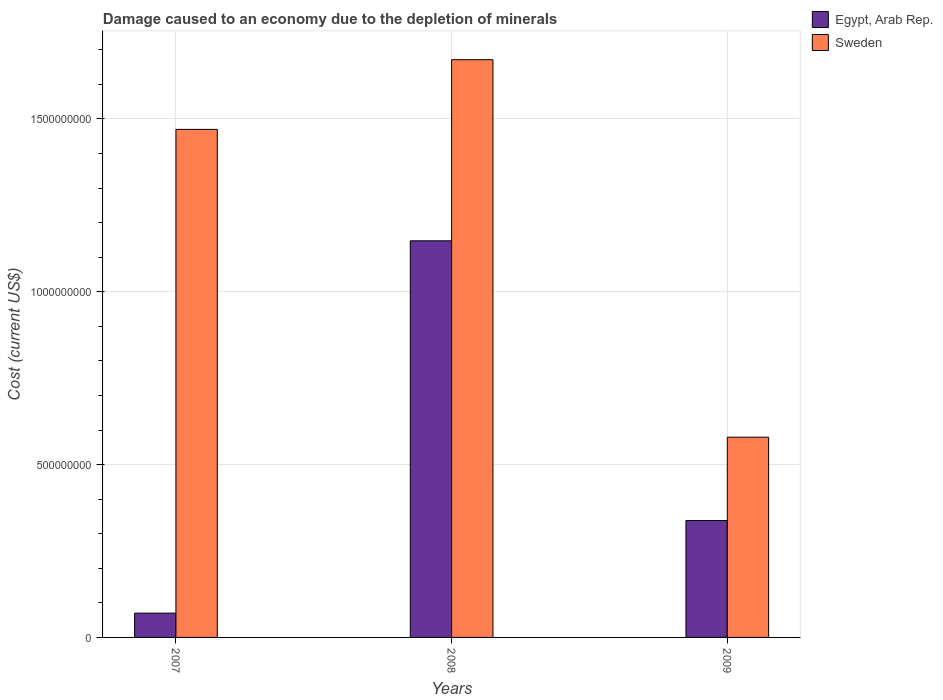How many different coloured bars are there?
Your answer should be very brief. 2. How many groups of bars are there?
Your answer should be compact. 3. Are the number of bars per tick equal to the number of legend labels?
Offer a terse response. Yes. How many bars are there on the 2nd tick from the left?
Offer a very short reply. 2. What is the label of the 2nd group of bars from the left?
Ensure brevity in your answer.  2008. What is the cost of damage caused due to the depletion of minerals in Sweden in 2008?
Provide a short and direct response. 1.67e+09. Across all years, what is the maximum cost of damage caused due to the depletion of minerals in Egypt, Arab Rep.?
Ensure brevity in your answer.  1.15e+09. Across all years, what is the minimum cost of damage caused due to the depletion of minerals in Sweden?
Keep it short and to the point. 5.79e+08. In which year was the cost of damage caused due to the depletion of minerals in Sweden minimum?
Give a very brief answer. 2009. What is the total cost of damage caused due to the depletion of minerals in Sweden in the graph?
Offer a terse response. 3.72e+09. What is the difference between the cost of damage caused due to the depletion of minerals in Egypt, Arab Rep. in 2007 and that in 2009?
Offer a terse response. -2.68e+08. What is the difference between the cost of damage caused due to the depletion of minerals in Sweden in 2007 and the cost of damage caused due to the depletion of minerals in Egypt, Arab Rep. in 2008?
Give a very brief answer. 3.22e+08. What is the average cost of damage caused due to the depletion of minerals in Egypt, Arab Rep. per year?
Ensure brevity in your answer.  5.19e+08. In the year 2007, what is the difference between the cost of damage caused due to the depletion of minerals in Sweden and cost of damage caused due to the depletion of minerals in Egypt, Arab Rep.?
Your response must be concise. 1.40e+09. What is the ratio of the cost of damage caused due to the depletion of minerals in Sweden in 2007 to that in 2008?
Ensure brevity in your answer.  0.88. What is the difference between the highest and the second highest cost of damage caused due to the depletion of minerals in Egypt, Arab Rep.?
Offer a very short reply. 8.09e+08. What is the difference between the highest and the lowest cost of damage caused due to the depletion of minerals in Egypt, Arab Rep.?
Provide a short and direct response. 1.08e+09. What does the 2nd bar from the left in 2009 represents?
Keep it short and to the point. Sweden. What does the 1st bar from the right in 2008 represents?
Give a very brief answer. Sweden. How many bars are there?
Offer a very short reply. 6. Does the graph contain any zero values?
Keep it short and to the point. No. Does the graph contain grids?
Offer a very short reply. Yes. How are the legend labels stacked?
Keep it short and to the point. Vertical. What is the title of the graph?
Offer a very short reply. Damage caused to an economy due to the depletion of minerals. Does "Pakistan" appear as one of the legend labels in the graph?
Ensure brevity in your answer.  No. What is the label or title of the X-axis?
Give a very brief answer. Years. What is the label or title of the Y-axis?
Make the answer very short. Cost (current US$). What is the Cost (current US$) of Egypt, Arab Rep. in 2007?
Your response must be concise. 7.03e+07. What is the Cost (current US$) in Sweden in 2007?
Give a very brief answer. 1.47e+09. What is the Cost (current US$) in Egypt, Arab Rep. in 2008?
Your answer should be compact. 1.15e+09. What is the Cost (current US$) of Sweden in 2008?
Provide a succinct answer. 1.67e+09. What is the Cost (current US$) of Egypt, Arab Rep. in 2009?
Offer a very short reply. 3.38e+08. What is the Cost (current US$) of Sweden in 2009?
Give a very brief answer. 5.79e+08. Across all years, what is the maximum Cost (current US$) of Egypt, Arab Rep.?
Make the answer very short. 1.15e+09. Across all years, what is the maximum Cost (current US$) of Sweden?
Offer a very short reply. 1.67e+09. Across all years, what is the minimum Cost (current US$) of Egypt, Arab Rep.?
Keep it short and to the point. 7.03e+07. Across all years, what is the minimum Cost (current US$) of Sweden?
Keep it short and to the point. 5.79e+08. What is the total Cost (current US$) in Egypt, Arab Rep. in the graph?
Make the answer very short. 1.56e+09. What is the total Cost (current US$) of Sweden in the graph?
Keep it short and to the point. 3.72e+09. What is the difference between the Cost (current US$) in Egypt, Arab Rep. in 2007 and that in 2008?
Make the answer very short. -1.08e+09. What is the difference between the Cost (current US$) of Sweden in 2007 and that in 2008?
Keep it short and to the point. -2.02e+08. What is the difference between the Cost (current US$) in Egypt, Arab Rep. in 2007 and that in 2009?
Make the answer very short. -2.68e+08. What is the difference between the Cost (current US$) of Sweden in 2007 and that in 2009?
Make the answer very short. 8.91e+08. What is the difference between the Cost (current US$) in Egypt, Arab Rep. in 2008 and that in 2009?
Provide a succinct answer. 8.09e+08. What is the difference between the Cost (current US$) in Sweden in 2008 and that in 2009?
Offer a terse response. 1.09e+09. What is the difference between the Cost (current US$) in Egypt, Arab Rep. in 2007 and the Cost (current US$) in Sweden in 2008?
Give a very brief answer. -1.60e+09. What is the difference between the Cost (current US$) in Egypt, Arab Rep. in 2007 and the Cost (current US$) in Sweden in 2009?
Offer a terse response. -5.09e+08. What is the difference between the Cost (current US$) of Egypt, Arab Rep. in 2008 and the Cost (current US$) of Sweden in 2009?
Your answer should be compact. 5.68e+08. What is the average Cost (current US$) in Egypt, Arab Rep. per year?
Offer a very short reply. 5.19e+08. What is the average Cost (current US$) in Sweden per year?
Your answer should be compact. 1.24e+09. In the year 2007, what is the difference between the Cost (current US$) in Egypt, Arab Rep. and Cost (current US$) in Sweden?
Ensure brevity in your answer.  -1.40e+09. In the year 2008, what is the difference between the Cost (current US$) in Egypt, Arab Rep. and Cost (current US$) in Sweden?
Offer a terse response. -5.24e+08. In the year 2009, what is the difference between the Cost (current US$) in Egypt, Arab Rep. and Cost (current US$) in Sweden?
Offer a terse response. -2.41e+08. What is the ratio of the Cost (current US$) in Egypt, Arab Rep. in 2007 to that in 2008?
Offer a very short reply. 0.06. What is the ratio of the Cost (current US$) in Sweden in 2007 to that in 2008?
Offer a terse response. 0.88. What is the ratio of the Cost (current US$) of Egypt, Arab Rep. in 2007 to that in 2009?
Ensure brevity in your answer.  0.21. What is the ratio of the Cost (current US$) of Sweden in 2007 to that in 2009?
Ensure brevity in your answer.  2.54. What is the ratio of the Cost (current US$) of Egypt, Arab Rep. in 2008 to that in 2009?
Your answer should be compact. 3.39. What is the ratio of the Cost (current US$) of Sweden in 2008 to that in 2009?
Offer a terse response. 2.88. What is the difference between the highest and the second highest Cost (current US$) of Egypt, Arab Rep.?
Your response must be concise. 8.09e+08. What is the difference between the highest and the second highest Cost (current US$) of Sweden?
Provide a succinct answer. 2.02e+08. What is the difference between the highest and the lowest Cost (current US$) of Egypt, Arab Rep.?
Your answer should be very brief. 1.08e+09. What is the difference between the highest and the lowest Cost (current US$) in Sweden?
Your response must be concise. 1.09e+09. 